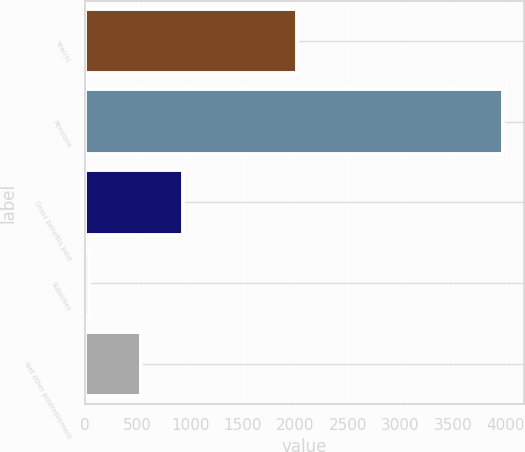Convert chart to OTSL. <chart><loc_0><loc_0><loc_500><loc_500><bar_chart><fcel>Year(s)<fcel>Pensions<fcel>Gross benefits paid<fcel>Subsidies<fcel>Net other postretirement<nl><fcel>2019<fcel>3977<fcel>929.5<fcel>42<fcel>536<nl></chart> 